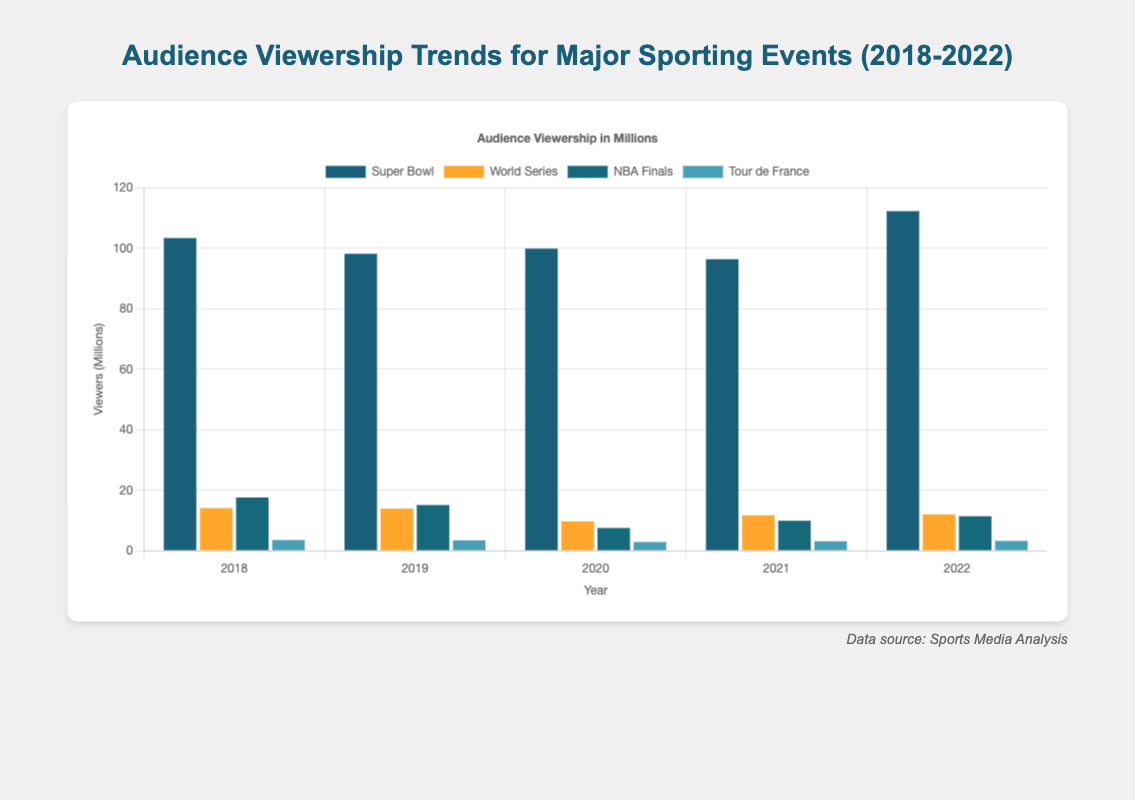What event had the highest viewership in 2022? To find the event with the highest viewership in 2022, compare the bars for each event in that year. The Super Bowl has the tallest bar, indicating it had the highest viewership.
Answer: Super Bowl How did the viewership for the Tour de France change from 2018 to 2022? Compare the bar heights for the Tour de France across the years. The viewership went from 3.52 million in 2018 to 3.25 million in 2022.
Answer: Decreased Which event had the lowest viewership in 2020, and what was it? Look at the shortest bars in 2020 and compare them. The Tour de France had the lowest viewership with 2.87 million viewers.
Answer: Tour de France, 2.87 million By how many millions of viewers did the Super Bowl viewership increase from 2021 to 2022? Subtract the viewership in 2021 from the viewership in 2022 for the Super Bowl: 112.3 million - 96.4 million = 15.9 million.
Answer: 15.9 million Compare the trend in viewership for the World Series and the NBA Finals from 2018 to 2022. Which event saw a more significant decline? For the World Series: compare 2018 to 2022 viewership (14.1 to 12.0 = -2.1 million). For the NBA Finals: compare 2018 to 2022 viewership (17.6 to 11.4 = -6.2 million). The NBA Finals saw a more significant decline.
Answer: NBA Finals Which events had an increase in viewership from 2021 to 2022? Compare bar heights for each event between 2021 and 2022. The Super Bowl and NBA Finals showed an increase in viewership.
Answer: Super Bowl, NBA Finals What was the average viewership of the Super Bowl over these five years? Add the viewership numbers for the Super Bowl from 2018 to 2022 and divide by 5: (103.4 + 98.2 + 99.9 + 96.4 + 112.3) / 5 = 102.04 million.
Answer: 102.04 million By what percentage did the viewership of the World Series drop from 2019 to 2020? Calculate the percentage drop: (13.9 - 9.7) / 13.9 * 100 ≈ 30.22%.
Answer: 30.22% Which year had the lowest overall viewership across all events combined? Sum the viewership for all four events for each year and compare: 2020 has the lowest combined viewership: 99.9 + 9.7 + 7.5 + 2.87 = 119.97 million.
Answer: 2020 What is the combined viewership difference between the Super Bowl and Tour de France in 2022? Subtract the viewership of the Tour de France from the Super Bowl in 2022: 112.3 - 3.25 = 109.05 million.
Answer: 109.05 million 